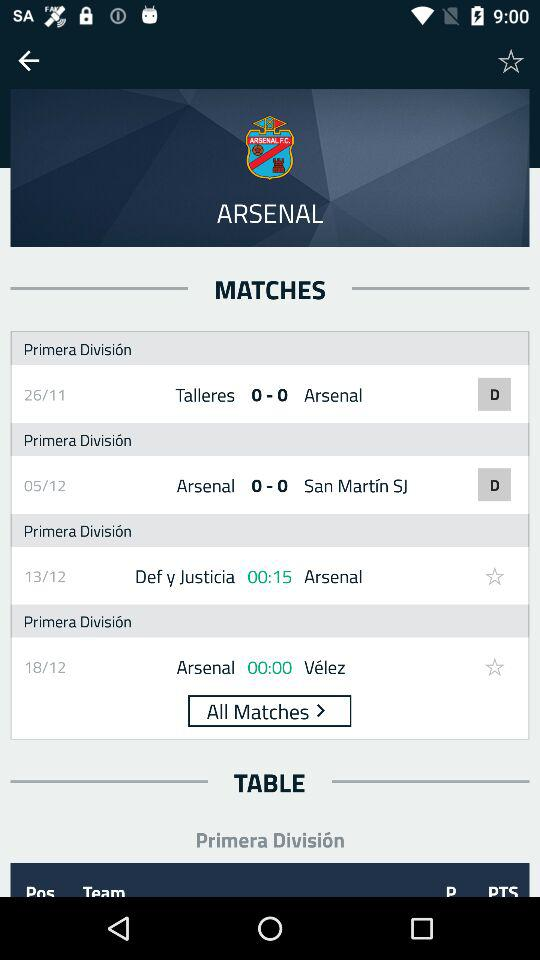When was the match between "Talleres" and "Arsenal" played? The match between "Talleres" and "Arsenal" was played on November 26. 